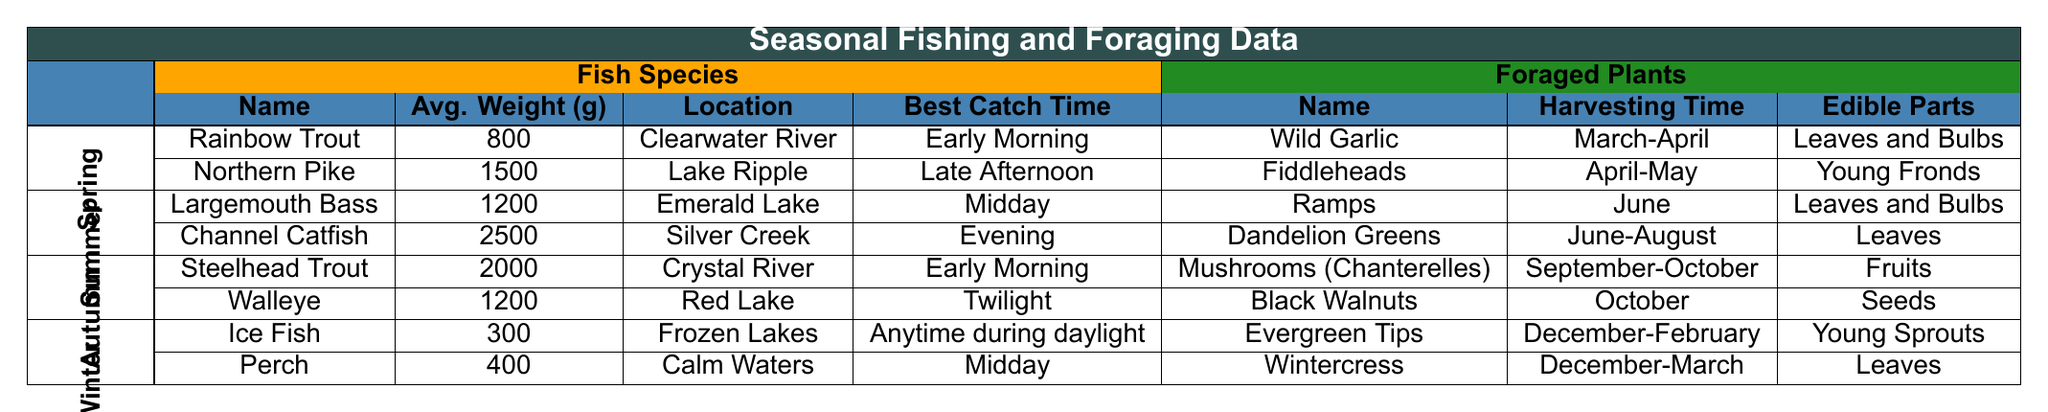What fish species has the highest average weight in Spring? In the Spring season, there are two fish species listed: Rainbow Trout (800 grams) and Northern Pike (1500 grams). The highest average weight among these is that of the Northern Pike, which is 1500 grams.
Answer: Northern Pike What is the best catch time for Steelhead Trout? The Steelhead Trout is caught best in the Early Morning, according to the table.
Answer: Early Morning Which foraged plant can be harvested in June? The table shows that Ramps can be harvested in June, as their harvesting time is specifically stated as June.
Answer: Ramps During which season can Black Walnuts be foraged? Black Walnuts can be harvested in October, which falls within the Autumn season according to the provided data.
Answer: Autumn What is the average weight of the fish species listed for Summer? For Summer, the fish species with their respective weights are Largemouth Bass (1200 grams) and Channel Catfish (2500 grams). The average weight is calculated as (1200 + 2500) / 2 = 1850 grams.
Answer: 1850 grams Is it true that Evergreen Tips can be harvested in February? The table states that Evergreen Tips can be harvested from December to February, so it is true that they are available in February.
Answer: Yes Which fish species listed for Winter has the lowest average weight? In Winter, the fish species are Ice Fish (300 grams) and Perch (400 grams). The Ice Fish has the lowest average weight of 300 grams.
Answer: Ice Fish What edible parts of Fiddleheads can be consumed? The table indicates that the edible parts of Fiddleheads are the Young Fronds.
Answer: Young Fronds In which location can you find the Largemouth Bass? According to the table, the Largemouth Bass can be found in Emerald Lake.
Answer: Emerald Lake What is the best catch time for Channel Catfish compared to the other fish species in Summer? The best catch time for Channel Catfish is in the Evening, while Largemouth Bass is best caught at Midday. Evening comes after Midday in a typical daily schedule, indicating Channel Catfish is best caught later in the day.
Answer: Evening How many different fish species are listed for the Autumn season? The Autumn season includes two fish species: Steelhead Trout and Walleye, which totals to two species.
Answer: 2 